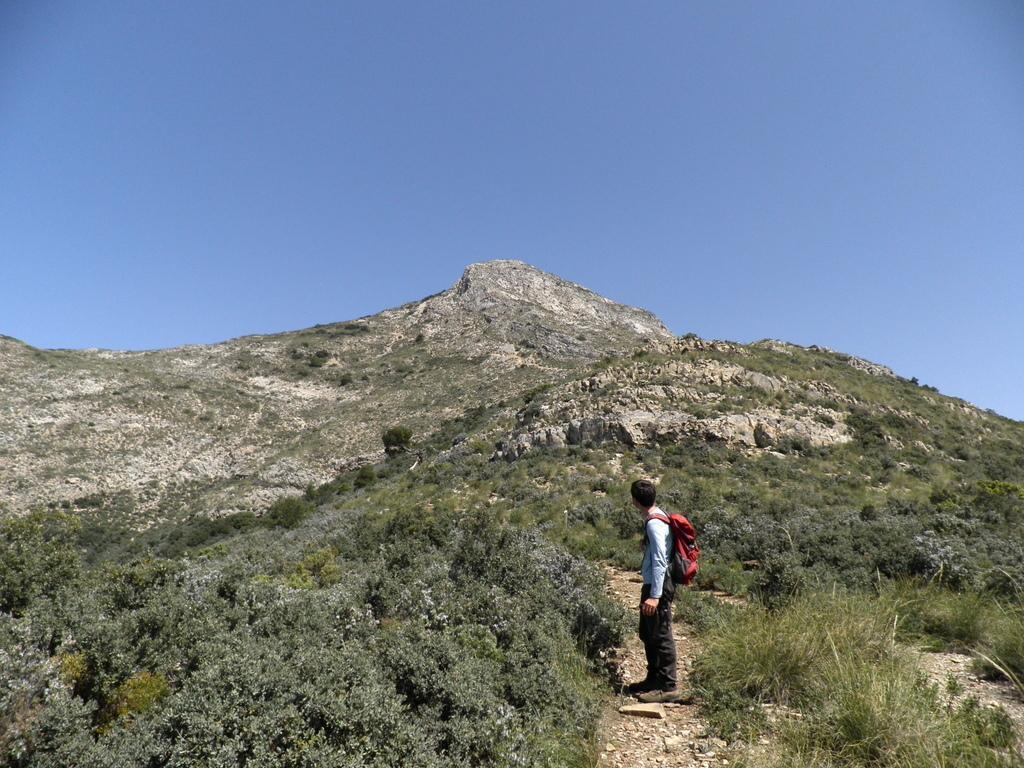In one or two sentences, can you explain what this image depicts? It looks like a hill station,a man is standing on a hill he is wearing a red color bag, in the background there are a lot of trees and a mountain and sky. 